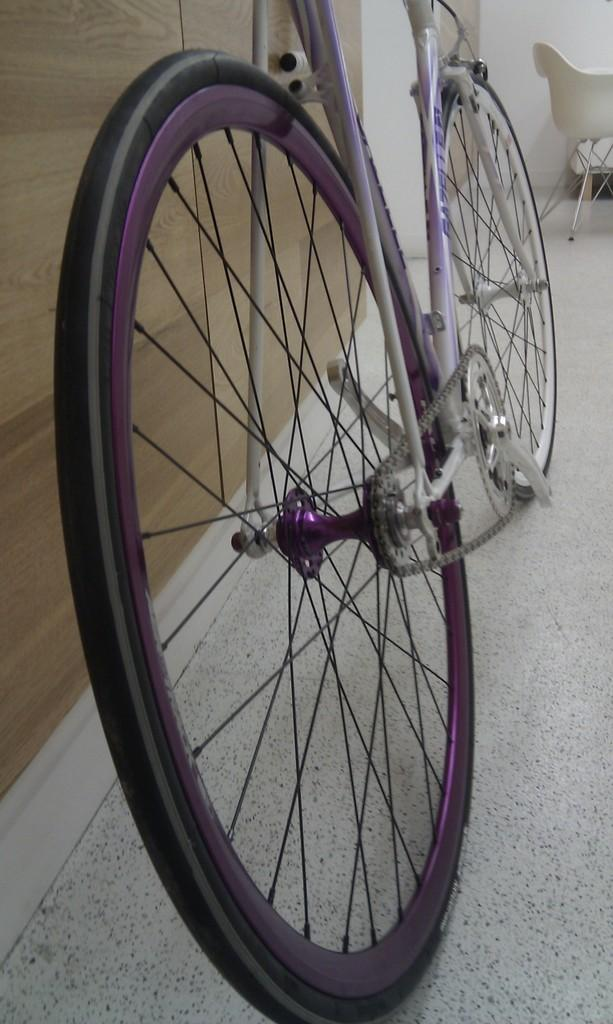What is the main object in the image? There is a bicycle in the image. How is the bicycle positioned in the image? The bicycle is attached to a wall. What is the wall made of? The wall is made of wood. What colors are the bicycle in the image? The bicycle is in white and purple color. Can you see a girl holding a rake in the image? There is no girl holding a rake in the image. What type of tail is attached to the bicycle in the image? There is no tail attached to the bicycle in the image. 